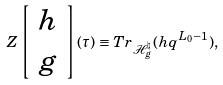Convert formula to latex. <formula><loc_0><loc_0><loc_500><loc_500>Z \left [ \begin{array} { c } h \\ g \end{array} \right ] ( \tau ) \equiv T r _ { \mathcal { H } _ { g } ^ { \natural } } ( h q ^ { L _ { 0 } - 1 } ) ,</formula> 